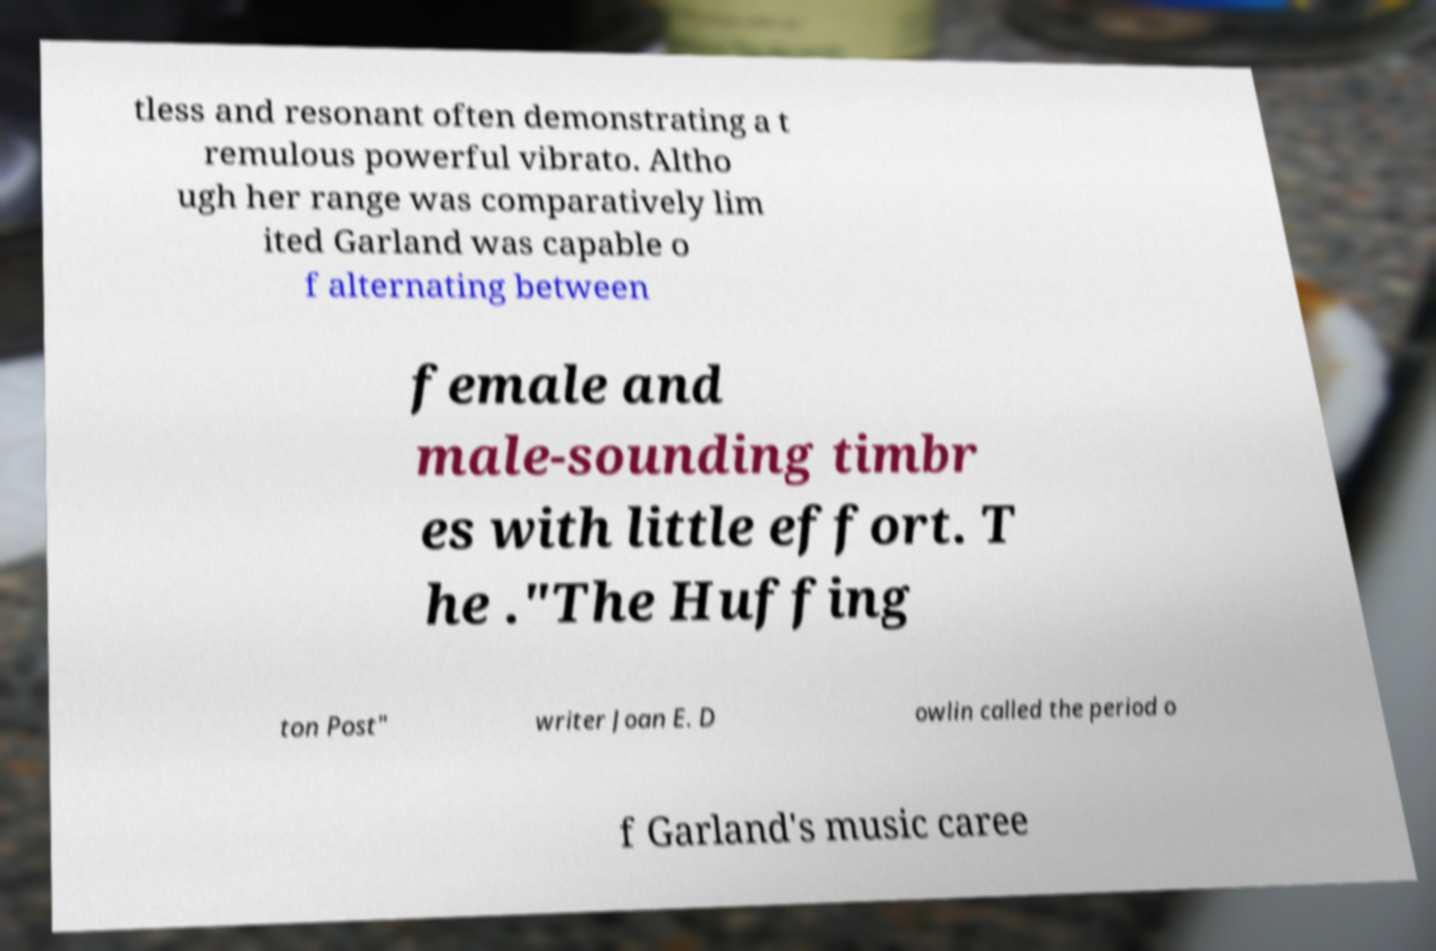Please identify and transcribe the text found in this image. tless and resonant often demonstrating a t remulous powerful vibrato. Altho ugh her range was comparatively lim ited Garland was capable o f alternating between female and male-sounding timbr es with little effort. T he ."The Huffing ton Post" writer Joan E. D owlin called the period o f Garland's music caree 